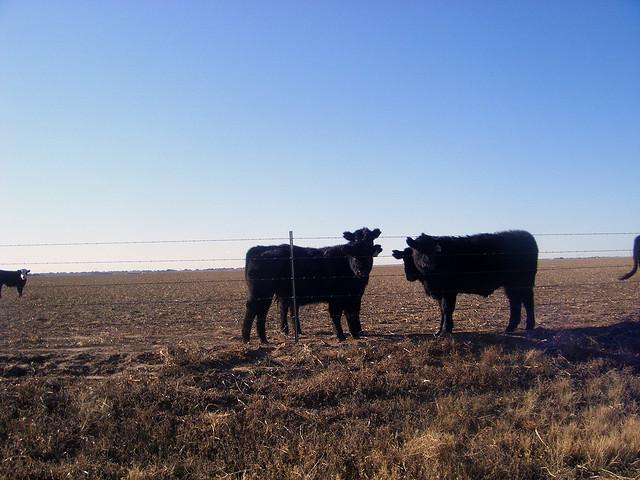Is the fence taller than the cow?
Concise answer only. No. Does a cow have a white face?
Give a very brief answer. No. What color is the grass?
Answer briefly. Brown. What type of animal is this?
Answer briefly. Cow. What is in the middle of the picture?
Write a very short answer. Cow. What is the fence made out of?
Concise answer only. Wire. Is the sky clear?
Short answer required. Yes. Are the cows in front of or behind the fence?
Be succinct. Behind. What color is the cow closest to the fence?
Quick response, please. Black. Are there clouds covering most of the sky?
Keep it brief. No. 